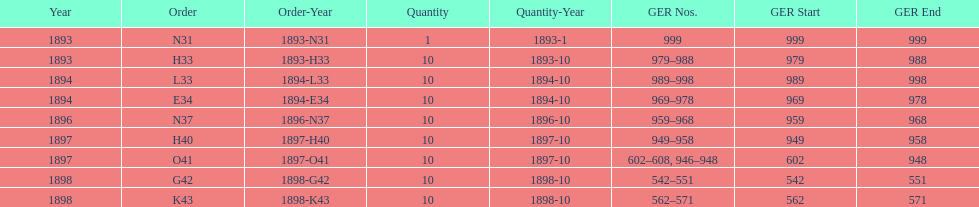In which year was g42, 1898 or 1894? 1898. 